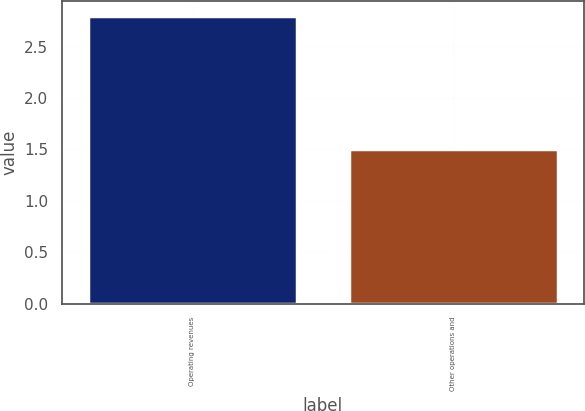Convert chart to OTSL. <chart><loc_0><loc_0><loc_500><loc_500><bar_chart><fcel>Operating revenues<fcel>Other operations and<nl><fcel>2.8<fcel>1.5<nl></chart> 